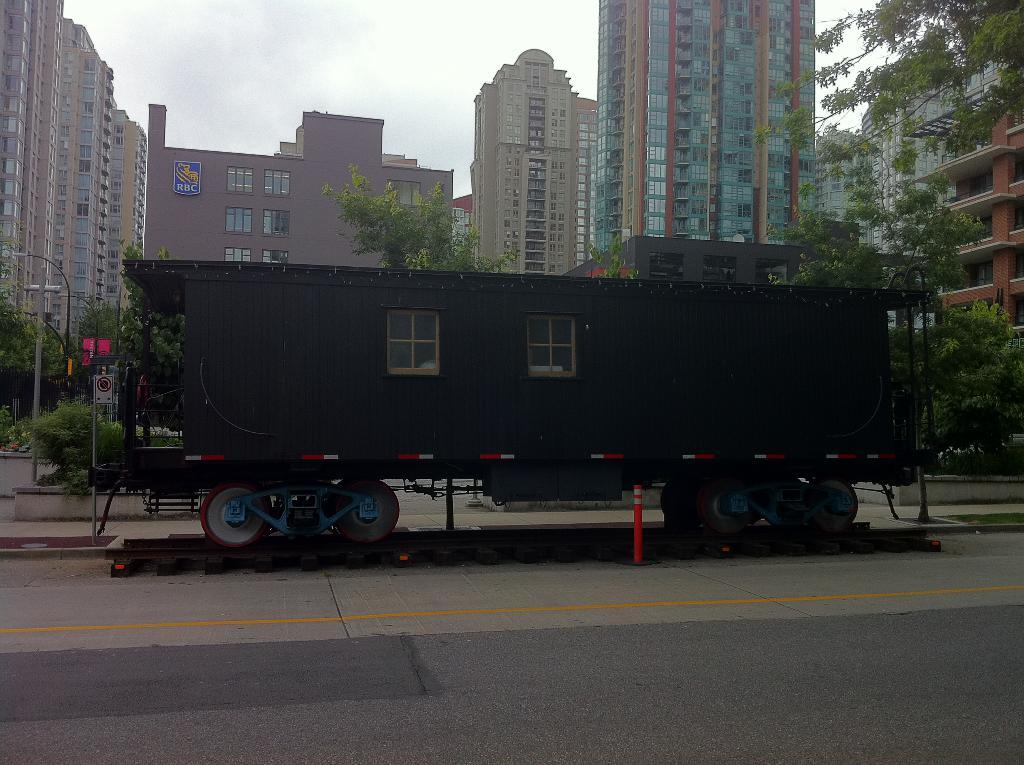What is the main subject of the image? The main subject of the image is a train on the railway track. What can be seen in the background of the image? In the background, there are buildings, windows, trees, light poles, and signboards visible. What is the color of the sky in the image? The sky appears to be white in color. What type of sack is being carried by the train's partner in the image? There is no partner or sack present in the image; it features a train on a railway track with a background of buildings, windows, trees, light poles, and signboards. 